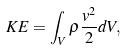<formula> <loc_0><loc_0><loc_500><loc_500>K E = \int _ { V } \rho \frac { { v } ^ { 2 } } { 2 } d V ,</formula> 